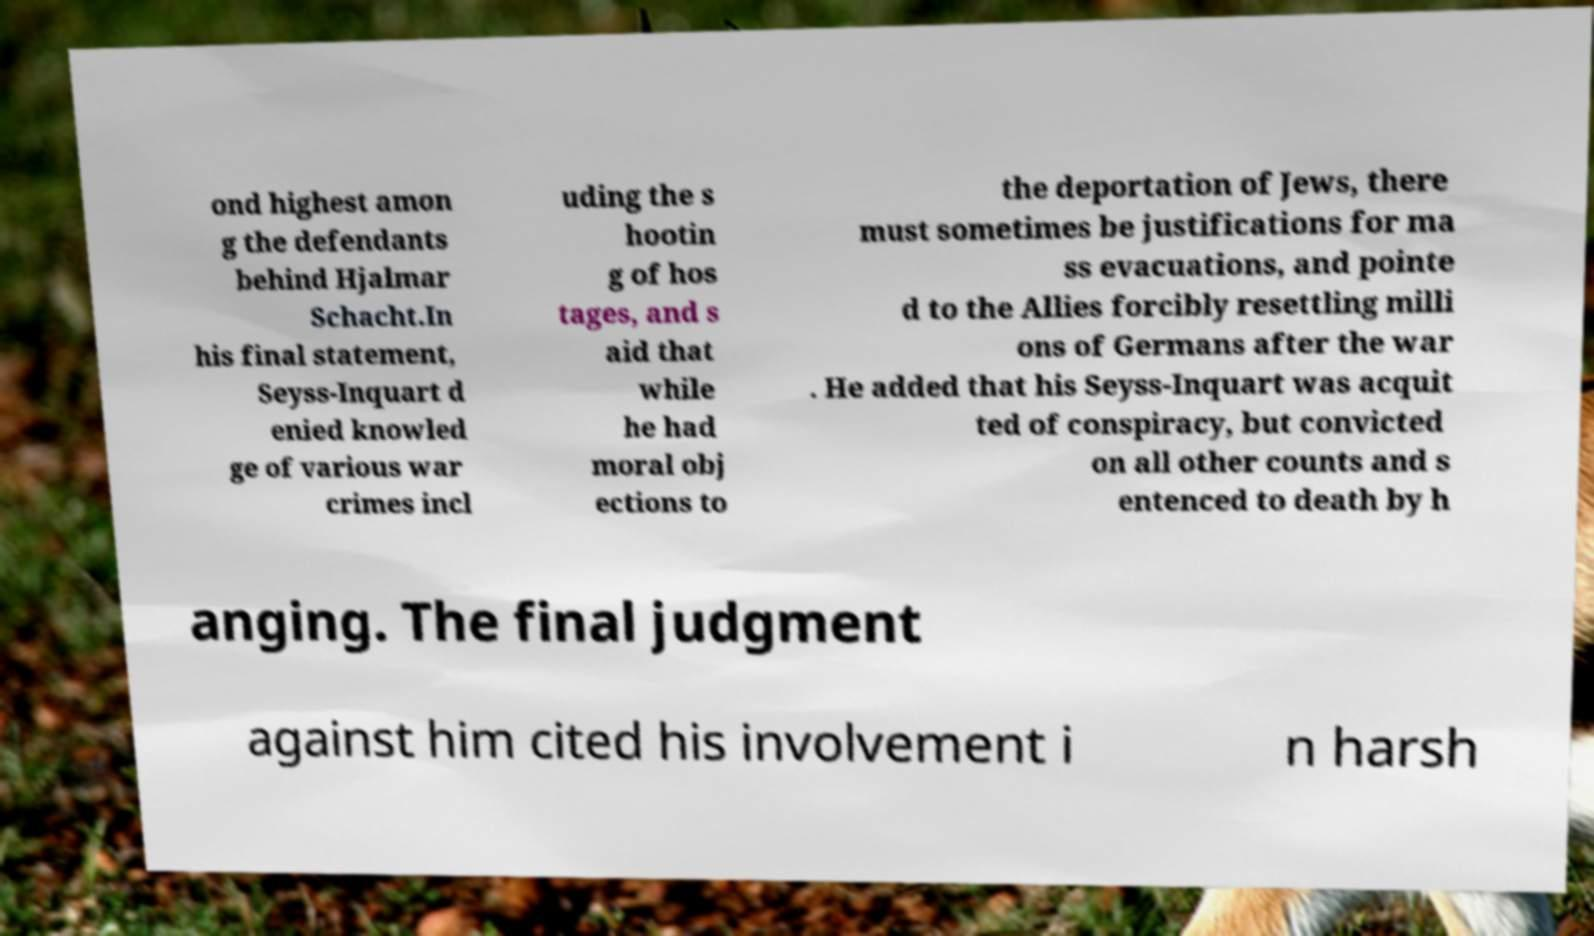I need the written content from this picture converted into text. Can you do that? ond highest amon g the defendants behind Hjalmar Schacht.In his final statement, Seyss-Inquart d enied knowled ge of various war crimes incl uding the s hootin g of hos tages, and s aid that while he had moral obj ections to the deportation of Jews, there must sometimes be justifications for ma ss evacuations, and pointe d to the Allies forcibly resettling milli ons of Germans after the war . He added that his Seyss-Inquart was acquit ted of conspiracy, but convicted on all other counts and s entenced to death by h anging. The final judgment against him cited his involvement i n harsh 